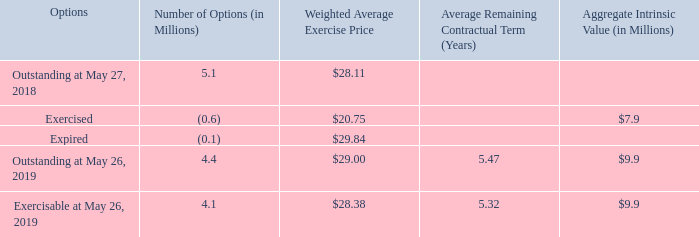A summary of the option activity as of May 26, 2019 and changes during the fiscal year then ended is presented below:
We recognize compensation expense using the straight-line method over the requisite service period, accounting for forfeitures as they occur. During fiscal 2017, we granted 1.1 million stock options with a weighted average grant date fair value of $6.12 per share. The total intrinsic value of stock options exercised was $7.9 million, $15.8 million, and $29.8 million for fiscal 2019, 2018, and 2017, respectively. The closing market price of our common stock on the last trading day of fiscal 2019 was $28.83 per share.
Compensation expense for stock option awards totaled $2.2 million, $4.2 million, and $6.2 million for fiscal 2019, 2018, and 2017, respectively, including discontinued operations of $0.2 million for fiscal 2017. Included in the compensation expense for stock option awards for fiscal 2019, 2018, and 2017 was $0.2 million, $0.4 million, and $0.9 million, respectively, related to stock options granted by a subsidiary in the subsidiary's shares to the subsidiary's employees. The tax benefit related to the stock option expense for fiscal 2019, 2018, and 2017 was $0.5 million, $1.4 million, and $2.4 million, respectively.
At May 26, 2019, we had $0.2 million of total unrecognized compensation expense related to stock options that will be recognized over a weighted average period of 0.1 years.
Cash received from stock option exercises for fiscal 2019, 2018, and 2017 was $12.4 million, $25.1 million, and $84.4 million, respectively. The actual tax benefit realized for the tax deductions from option exercises totaled $2.3 million, $5.3 million, and $19.5 million for fiscal 2019, 2018, and 2017, respectively.
What was the compensation expense for stock option awards during the fiscal year 2018? $4.2 million. What was the weighted average fair value per share for stock options granted during 2017? $6.12. How many options were exercisable as of May 26, 2019?
Answer scale should be: million. 4.1. What is the percentage change in the number of outstanding options from 2018 to 2019?
Answer scale should be: percent. (4.4-5.1)/5.1 
Answer: -13.73. What is the proportion of exercisable options over outstanding options as of May 26, 2019? 4.1 / 4.4 
Answer: 0.93. What is the total price of exercised and expired options?
Answer scale should be: million. (0.6*20.75)+(0.1*29.84) 
Answer: 15.43. 